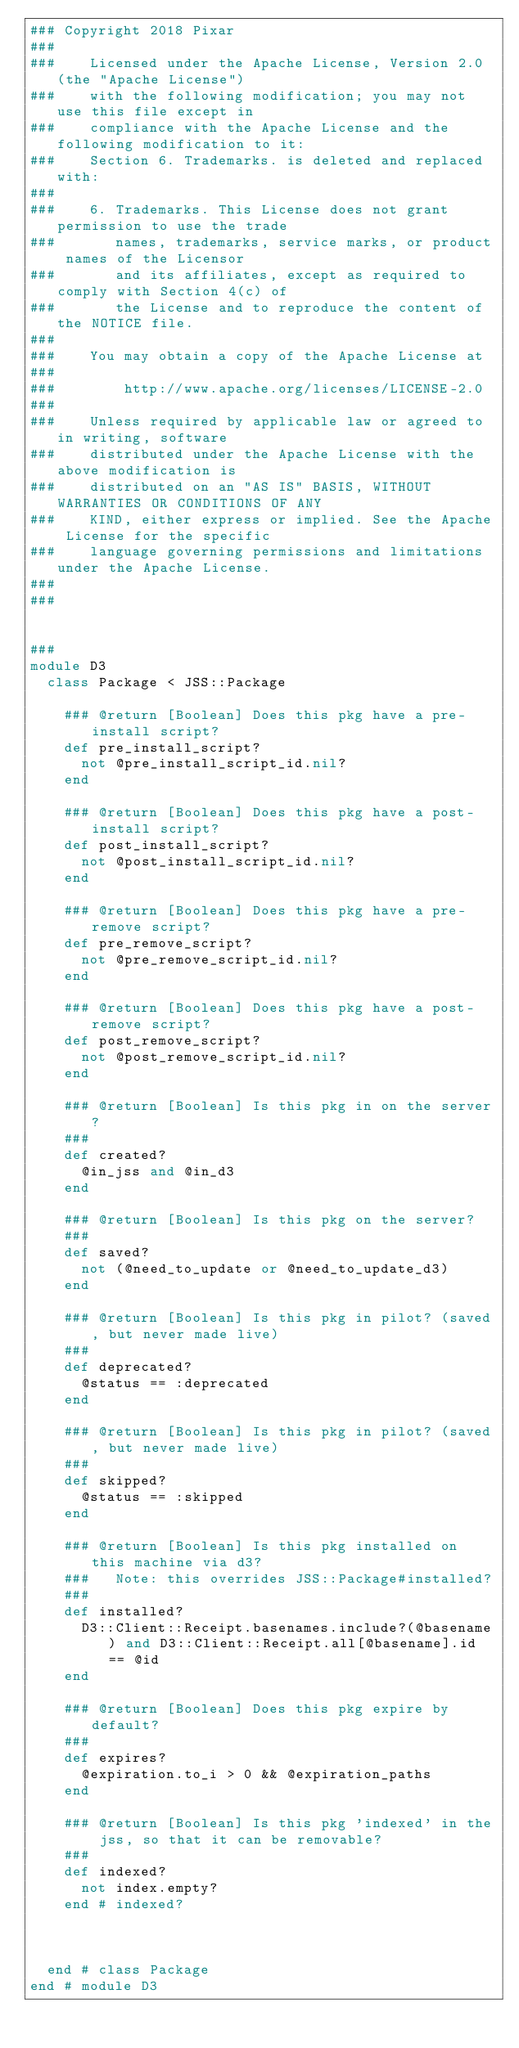<code> <loc_0><loc_0><loc_500><loc_500><_Ruby_>### Copyright 2018 Pixar
###
###    Licensed under the Apache License, Version 2.0 (the "Apache License")
###    with the following modification; you may not use this file except in
###    compliance with the Apache License and the following modification to it:
###    Section 6. Trademarks. is deleted and replaced with:
###
###    6. Trademarks. This License does not grant permission to use the trade
###       names, trademarks, service marks, or product names of the Licensor
###       and its affiliates, except as required to comply with Section 4(c) of
###       the License and to reproduce the content of the NOTICE file.
###
###    You may obtain a copy of the Apache License at
###
###        http://www.apache.org/licenses/LICENSE-2.0
###
###    Unless required by applicable law or agreed to in writing, software
###    distributed under the Apache License with the above modification is
###    distributed on an "AS IS" BASIS, WITHOUT WARRANTIES OR CONDITIONS OF ANY
###    KIND, either express or implied. See the Apache License for the specific
###    language governing permissions and limitations under the Apache License.
###
###


###
module D3
  class Package < JSS::Package

    ### @return [Boolean] Does this pkg have a pre-install script?
    def pre_install_script?
      not @pre_install_script_id.nil?
    end

    ### @return [Boolean] Does this pkg have a post-install script?
    def post_install_script?
      not @post_install_script_id.nil?
    end

    ### @return [Boolean] Does this pkg have a pre-remove script?
    def pre_remove_script?
      not @pre_remove_script_id.nil?
    end

    ### @return [Boolean] Does this pkg have a post-remove script?
    def post_remove_script?
      not @post_remove_script_id.nil?
    end

    ### @return [Boolean] Is this pkg in on the server?
    ###
    def created?
      @in_jss and @in_d3
    end

    ### @return [Boolean] Is this pkg on the server?
    ###
    def saved?
      not (@need_to_update or @need_to_update_d3)
    end

    ### @return [Boolean] Is this pkg in pilot? (saved, but never made live)
    ###
    def deprecated?
      @status == :deprecated
    end

    ### @return [Boolean] Is this pkg in pilot? (saved, but never made live)
    ###
    def skipped?
      @status == :skipped
    end

    ### @return [Boolean] Is this pkg installed on this machine via d3?
    ###   Note: this overrides JSS::Package#installed?
    ###
    def installed?
      D3::Client::Receipt.basenames.include?(@basename) and D3::Client::Receipt.all[@basename].id == @id
    end

    ### @return [Boolean] Does this pkg expire by default?
    ###
    def expires?
      @expiration.to_i > 0 && @expiration_paths
    end

    ### @return [Boolean] Is this pkg 'indexed' in the jss, so that it can be removable?
    ###
    def indexed?
      not index.empty?
    end # indexed?



  end # class Package
end # module D3
</code> 